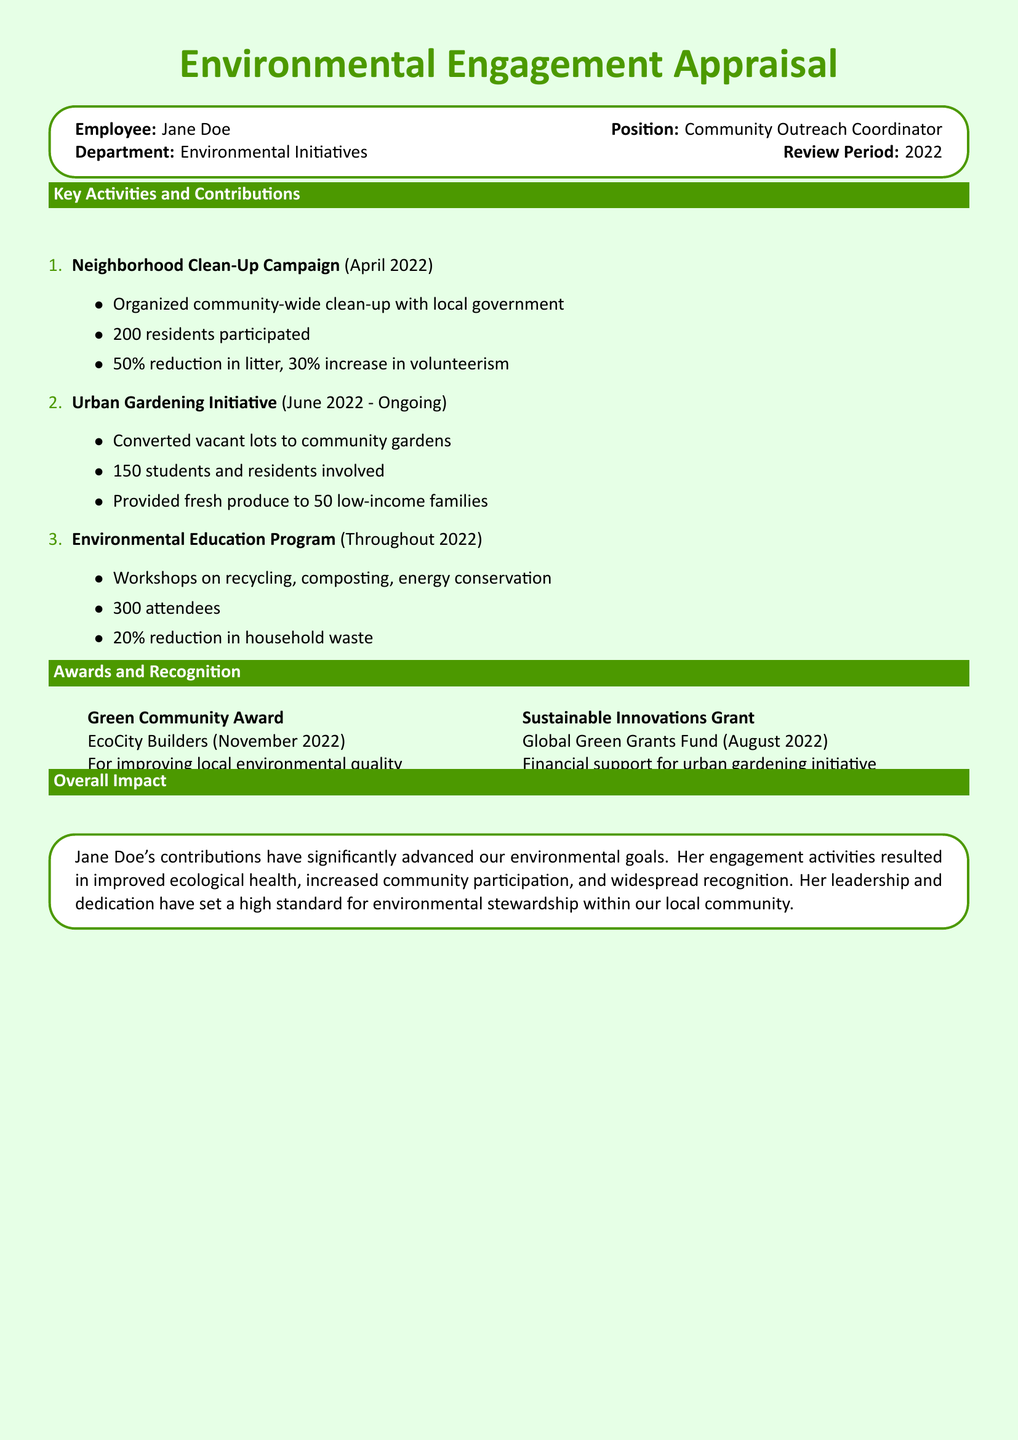What is the name of the employee? The employee's name is mentioned at the top of the document.
Answer: Jane Doe What position does Jane Doe hold? The position of the employee is stated alongside her name in the document.
Answer: Community Outreach Coordinator When did the Neighborhood Clean-Up Campaign take place? The date of the event is specified next to its title in the activities section.
Answer: April 2022 How many residents participated in the Neighborhood Clean-Up Campaign? The number of participants is listed under the campaign details.
Answer: 200 What percentage reduction in litter was achieved through the clean-up campaign? The reduction in litter is noted as a percentage in the campaign's impact description.
Answer: 50% Which award was received from EcoCity Builders? The awards and recognition section lists all awards, including their sources.
Answer: Green Community Award How many attendees were there in the Environmental Education Program? The number of attendees is specified in the description of the program activities.
Answer: 300 What is the name of the grant received for the urban gardening initiative? The grant's name is provided within the awards section of the document.
Answer: Sustainable Innovations Grant How many families received fresh produce from the Urban Gardening Initiative? The number of families benefited from the initiative is mentioned in the activities section.
Answer: 50 What was the overall impact of Jane Doe's contributions? This information is summarized in the overall impact section of the document.
Answer: Advanced environmental goals 